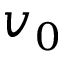<formula> <loc_0><loc_0><loc_500><loc_500>v _ { 0 }</formula> 